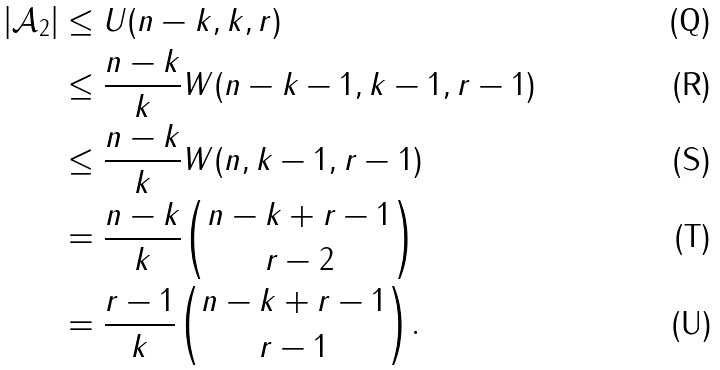<formula> <loc_0><loc_0><loc_500><loc_500>| \mathcal { A } _ { 2 } | & \leq U ( n - k , k , r ) \\ & \leq \frac { n - k } { k } W ( n - k - 1 , k - 1 , r - 1 ) \\ & \leq \frac { n - k } { k } W ( n , k - 1 , r - 1 ) \\ & = \frac { n - k } { k } \binom { n - k + r - 1 } { r - 2 } \\ & = \frac { r - 1 } { k } \binom { n - k + r - 1 } { r - 1 } .</formula> 